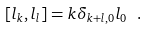Convert formula to latex. <formula><loc_0><loc_0><loc_500><loc_500>[ l _ { k } , l _ { l } ] = k \delta _ { k + l , 0 } l _ { 0 } \ .</formula> 